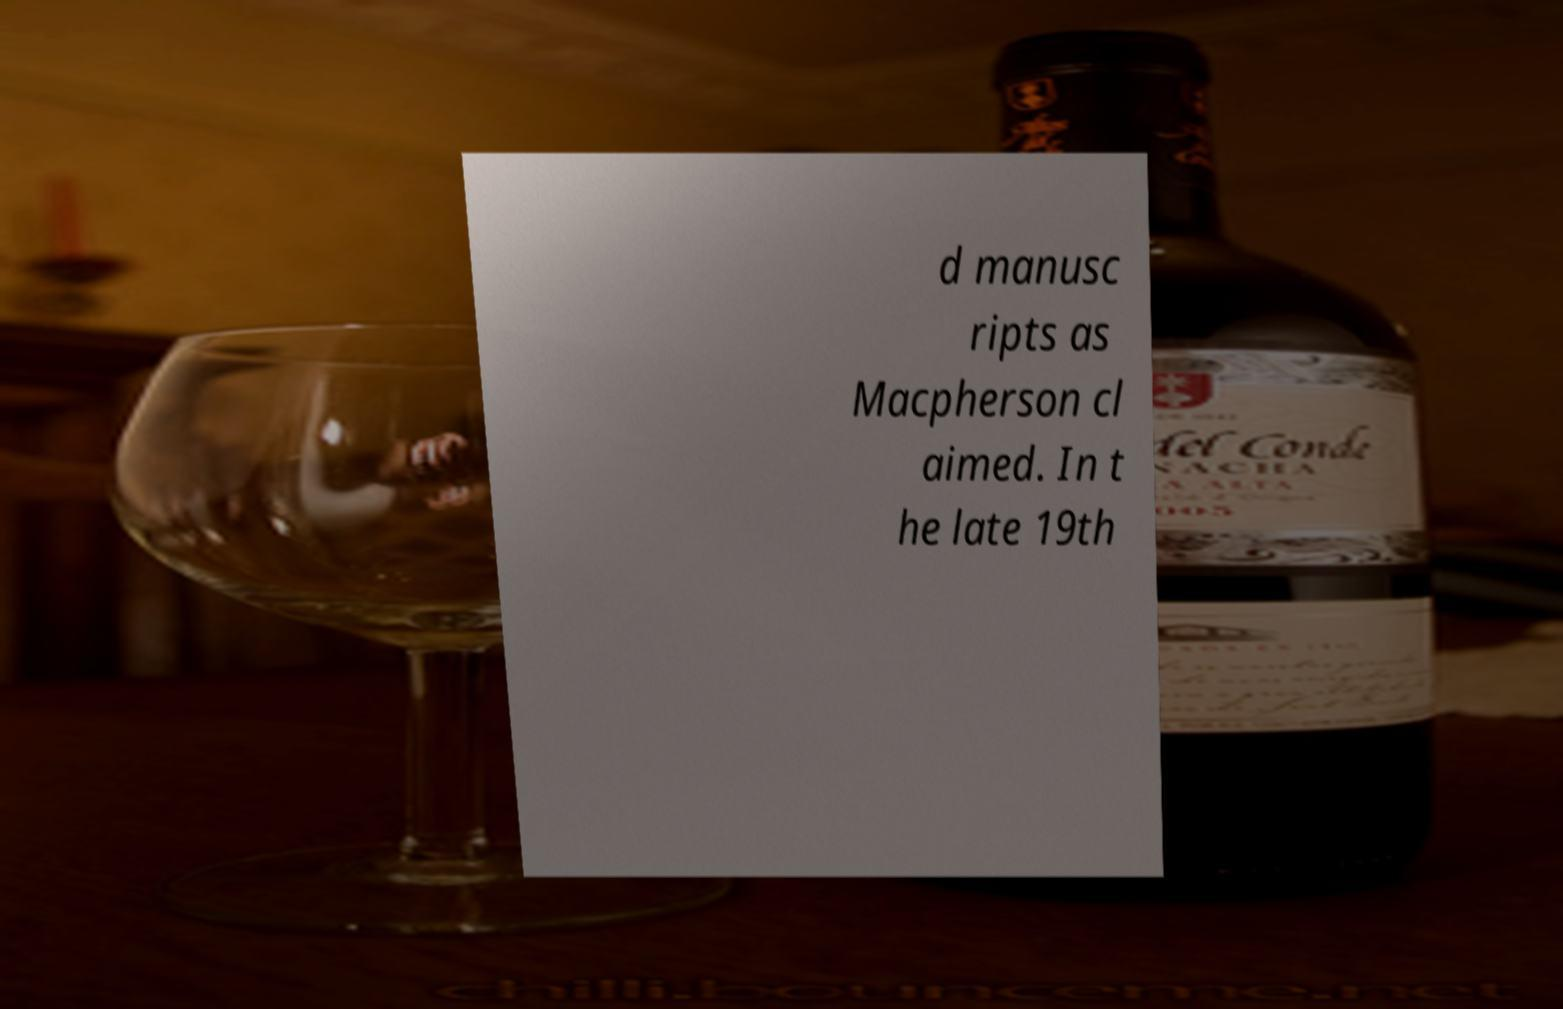Please identify and transcribe the text found in this image. d manusc ripts as Macpherson cl aimed. In t he late 19th 